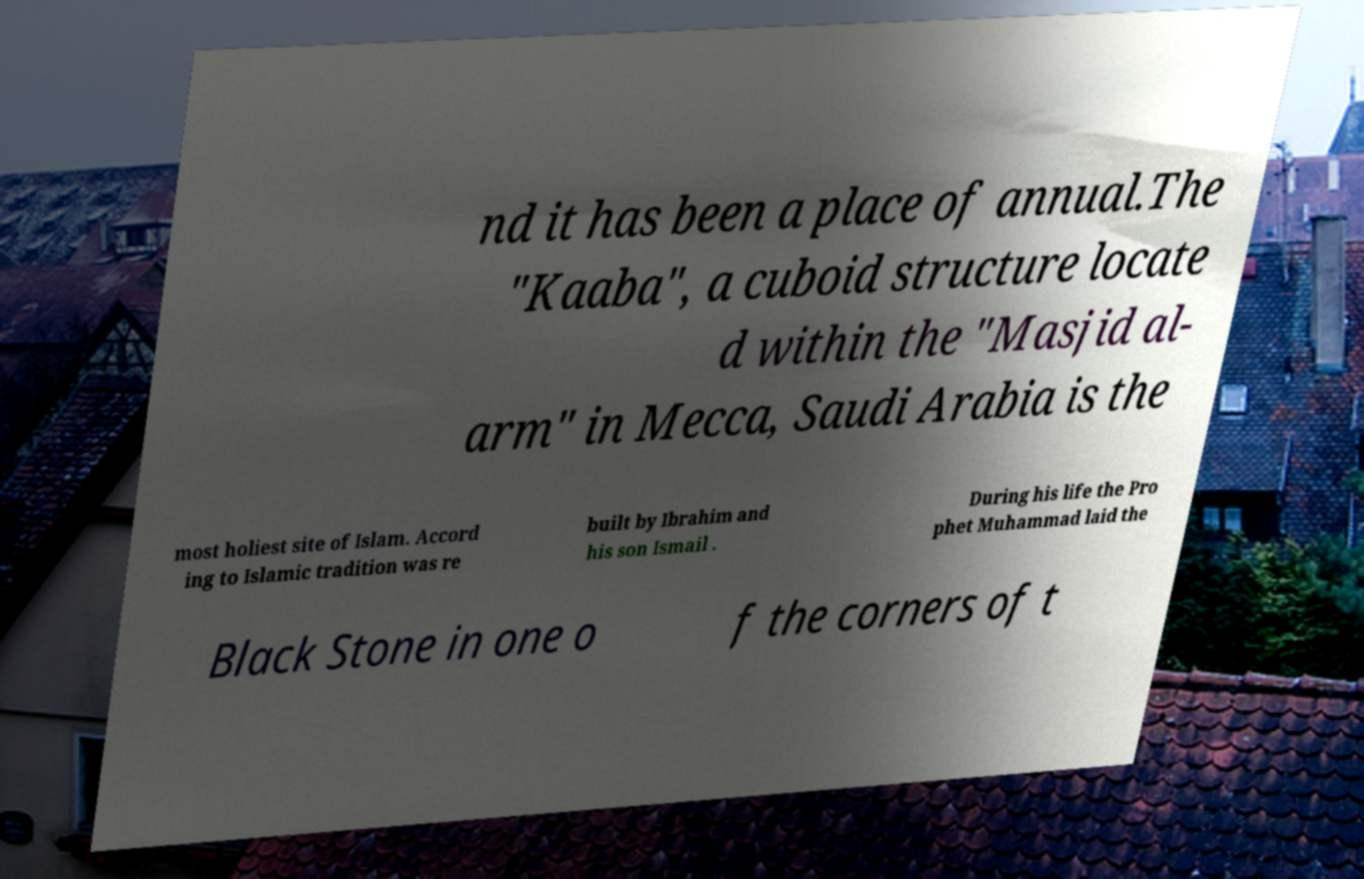What messages or text are displayed in this image? I need them in a readable, typed format. nd it has been a place of annual.The "Kaaba", a cuboid structure locate d within the "Masjid al- arm" in Mecca, Saudi Arabia is the most holiest site of Islam. Accord ing to Islamic tradition was re built by Ibrahim and his son Ismail . During his life the Pro phet Muhammad laid the Black Stone in one o f the corners of t 